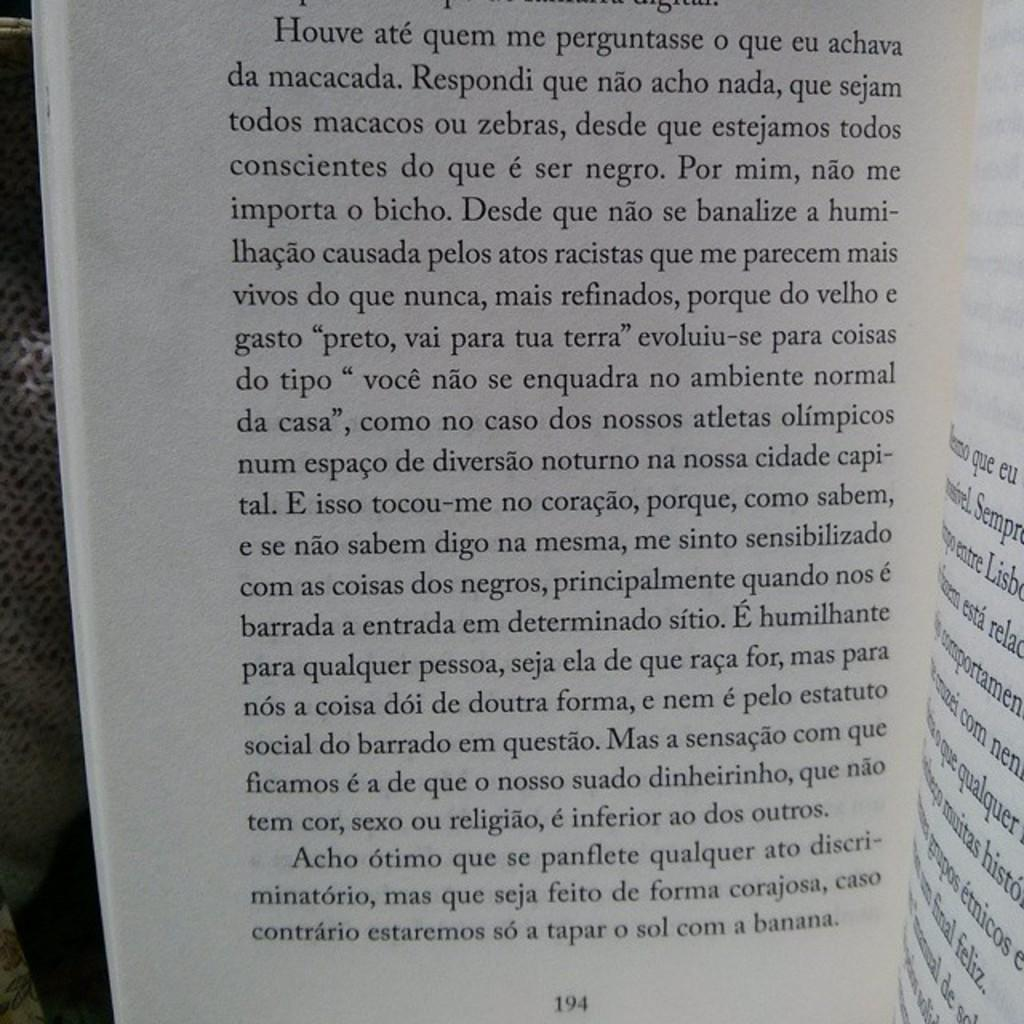Provide a one-sentence caption for the provided image. An open book that is on page 194. 